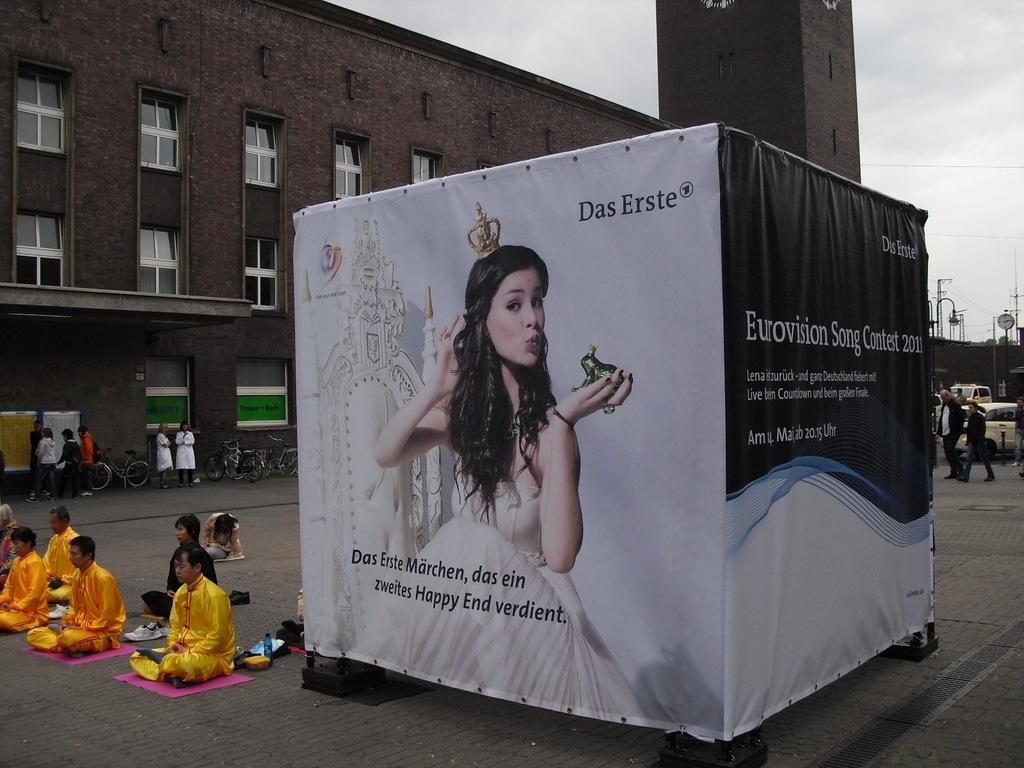What is the main object in the image? There is a board in the image. Who or what can be seen in the image? There are people in the image. What type of vehicles are on the road in the image? There are cars and bicycles on the road in the image. What can be seen in the background of the image? There are buildings, poles, and the sky visible in the background of the image. How many boats are visible in the image? There are no boats present in the image. What type of letters are being written on the board in the image? There is no indication of any letters being written on the board in the image. 